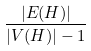<formula> <loc_0><loc_0><loc_500><loc_500>\frac { | E ( H ) | } { | V ( H ) | - 1 }</formula> 